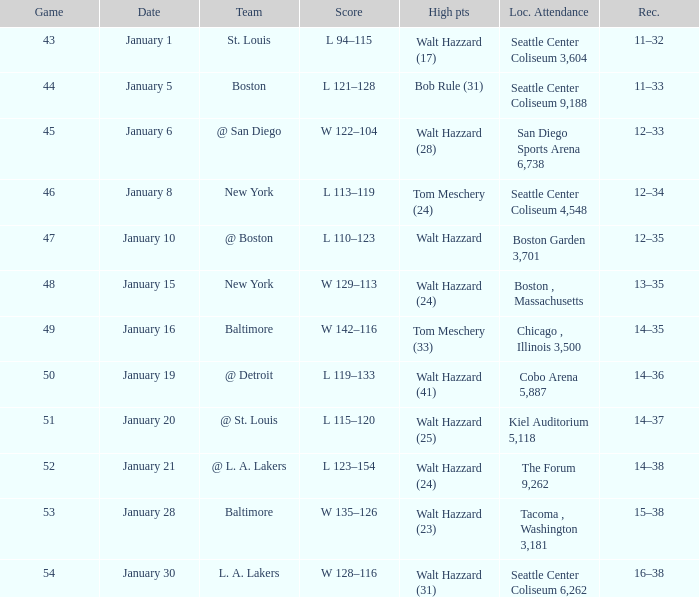What is the record for the St. Louis team? 11–32. 